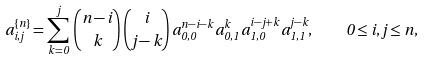Convert formula to latex. <formula><loc_0><loc_0><loc_500><loc_500>a _ { i , j } ^ { \{ n \} } = \sum _ { k = 0 } ^ { j } \, \binom { n - i } { k } \, \binom { i } { j - k } \, a _ { 0 , 0 } ^ { n - i - k } \, a _ { 0 , 1 } ^ { k } \, a _ { 1 , 0 } ^ { i - j + k } \, a _ { 1 , 1 } ^ { j - k } , \quad 0 \leq i , j \leq n ,</formula> 